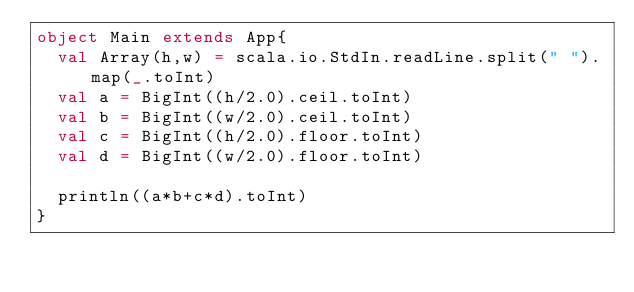Convert code to text. <code><loc_0><loc_0><loc_500><loc_500><_Scala_>object Main extends App{
  val Array(h,w) = scala.io.StdIn.readLine.split(" ").map(_.toInt)
  val a = BigInt((h/2.0).ceil.toInt)
  val b = BigInt((w/2.0).ceil.toInt)
  val c = BigInt((h/2.0).floor.toInt)
  val d = BigInt((w/2.0).floor.toInt)

  println((a*b+c*d).toInt)
}</code> 